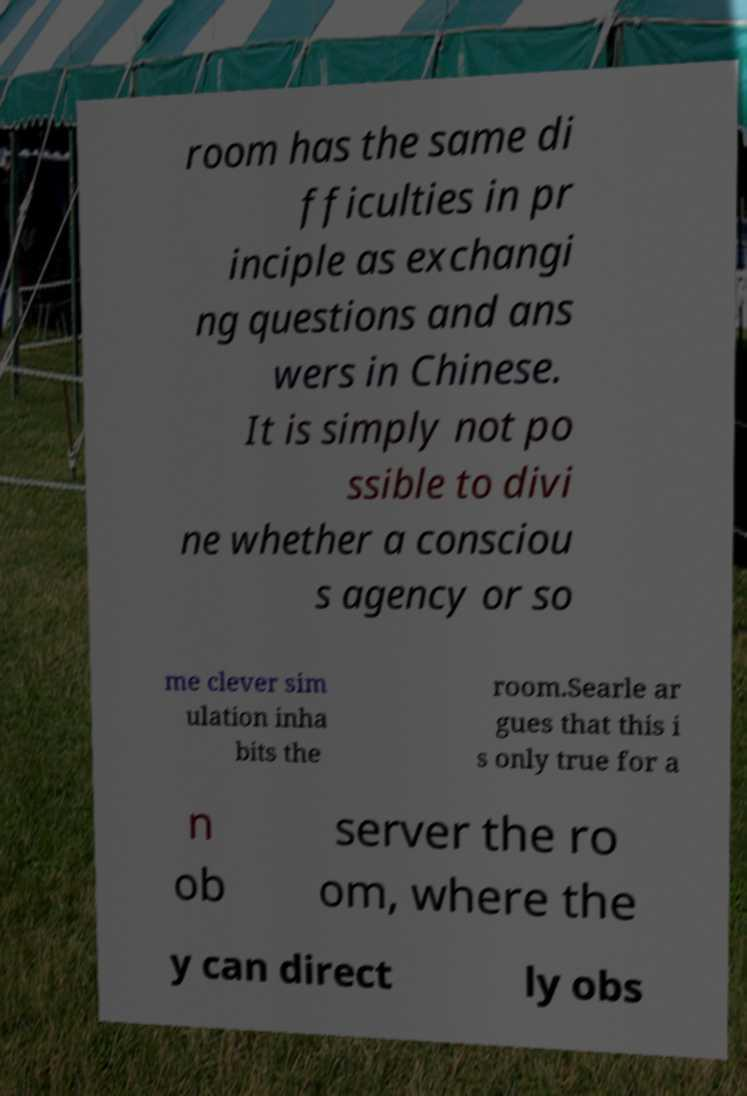Can you accurately transcribe the text from the provided image for me? room has the same di fficulties in pr inciple as exchangi ng questions and ans wers in Chinese. It is simply not po ssible to divi ne whether a consciou s agency or so me clever sim ulation inha bits the room.Searle ar gues that this i s only true for a n ob server the ro om, where the y can direct ly obs 